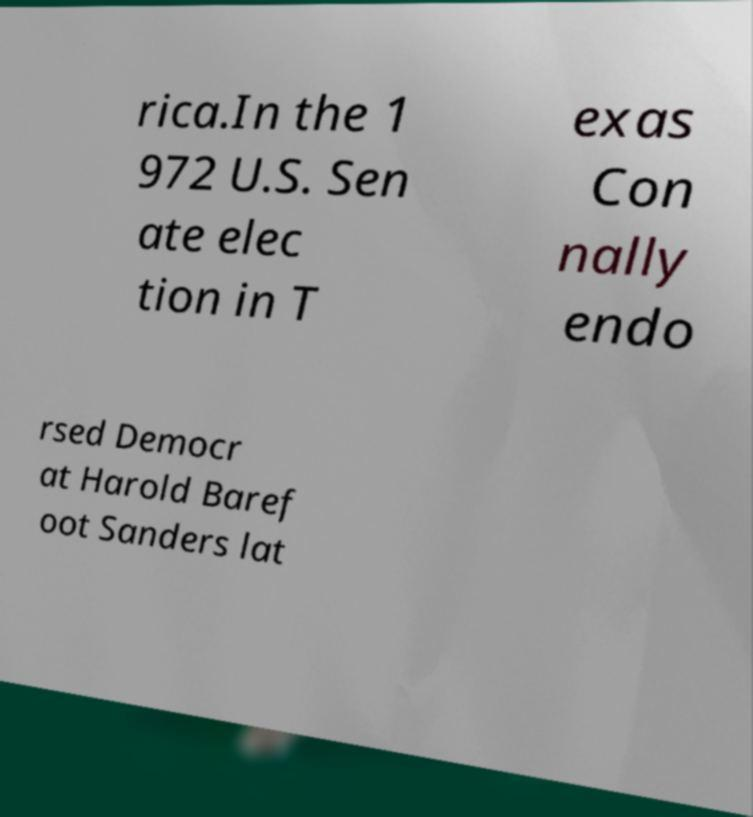What messages or text are displayed in this image? I need them in a readable, typed format. rica.In the 1 972 U.S. Sen ate elec tion in T exas Con nally endo rsed Democr at Harold Baref oot Sanders lat 